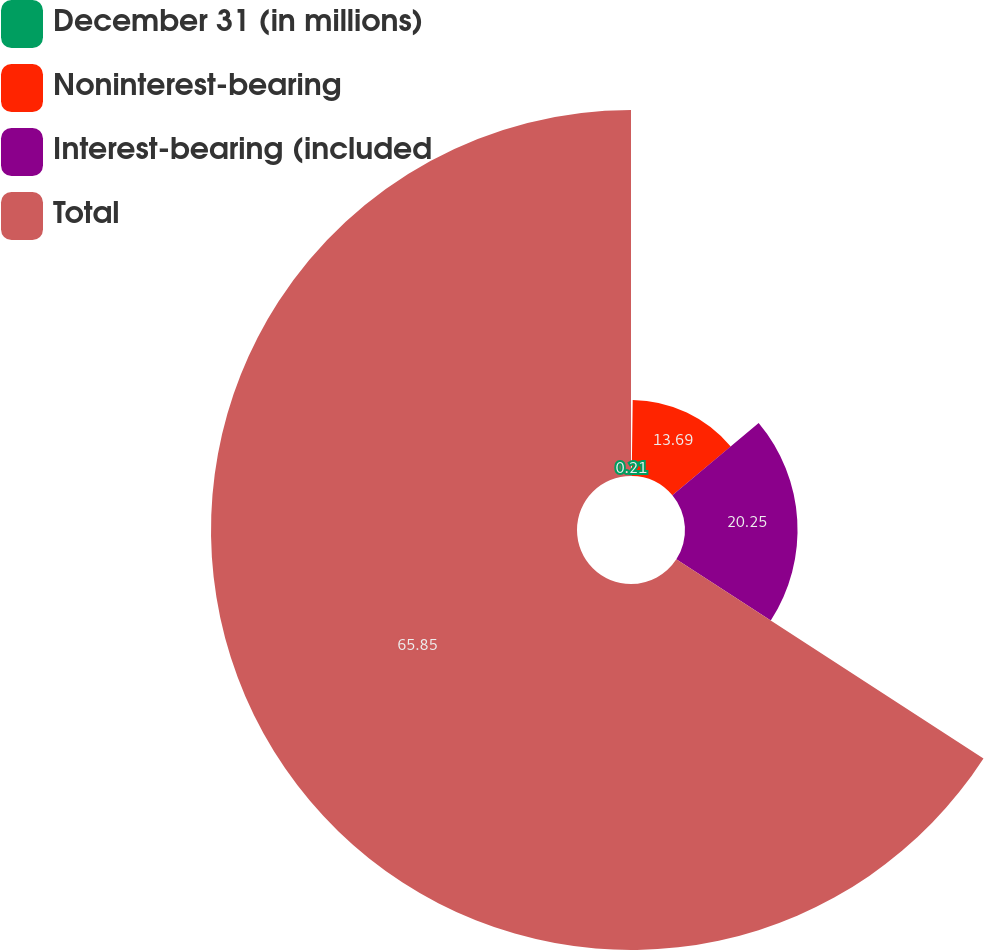Convert chart to OTSL. <chart><loc_0><loc_0><loc_500><loc_500><pie_chart><fcel>December 31 (in millions)<fcel>Noninterest-bearing<fcel>Interest-bearing (included<fcel>Total<nl><fcel>0.21%<fcel>13.69%<fcel>20.25%<fcel>65.85%<nl></chart> 